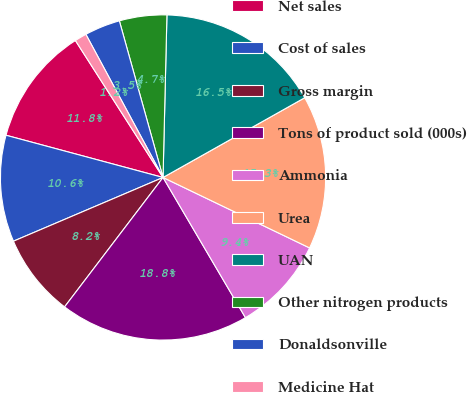Convert chart. <chart><loc_0><loc_0><loc_500><loc_500><pie_chart><fcel>Net sales<fcel>Cost of sales<fcel>Gross margin<fcel>Tons of product sold (000s)<fcel>Ammonia<fcel>Urea<fcel>UAN<fcel>Other nitrogen products<fcel>Donaldsonville<fcel>Medicine Hat<nl><fcel>11.76%<fcel>10.59%<fcel>8.24%<fcel>18.81%<fcel>9.41%<fcel>15.29%<fcel>16.46%<fcel>4.71%<fcel>3.54%<fcel>1.19%<nl></chart> 